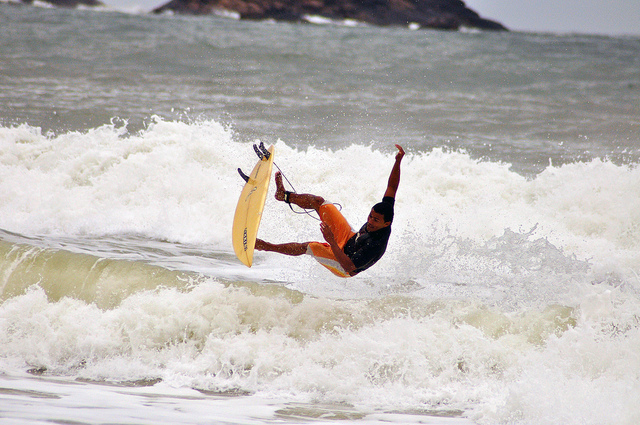What details can you provide about the surfer's equipment? The surfer is using a short, truncated surfboard, often referred to as a 'skimboard', which is suitable for performing tricks and managing sharp, fast waves. 